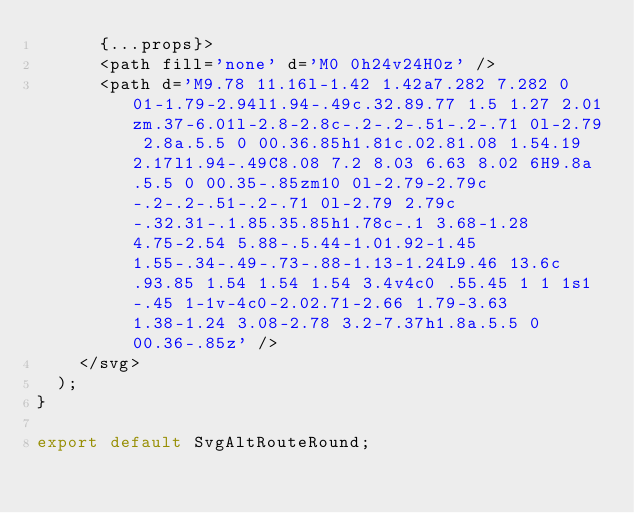Convert code to text. <code><loc_0><loc_0><loc_500><loc_500><_JavaScript_>			{...props}>
			<path fill='none' d='M0 0h24v24H0z' />
			<path d='M9.78 11.16l-1.42 1.42a7.282 7.282 0 01-1.79-2.94l1.94-.49c.32.89.77 1.5 1.27 2.01zm.37-6.01l-2.8-2.8c-.2-.2-.51-.2-.71 0l-2.79 2.8a.5.5 0 00.36.85h1.81c.02.81.08 1.54.19 2.17l1.94-.49C8.08 7.2 8.03 6.63 8.02 6H9.8a.5.5 0 00.35-.85zm10 0l-2.79-2.79c-.2-.2-.51-.2-.71 0l-2.79 2.79c-.32.31-.1.85.35.85h1.78c-.1 3.68-1.28 4.75-2.54 5.88-.5.44-1.01.92-1.45 1.55-.34-.49-.73-.88-1.13-1.24L9.46 13.6c.93.85 1.54 1.54 1.54 3.4v4c0 .55.45 1 1 1s1-.45 1-1v-4c0-2.02.71-2.66 1.79-3.63 1.38-1.24 3.08-2.78 3.2-7.37h1.8a.5.5 0 00.36-.85z' />
		</svg>
	);
}

export default SvgAltRouteRound;
</code> 